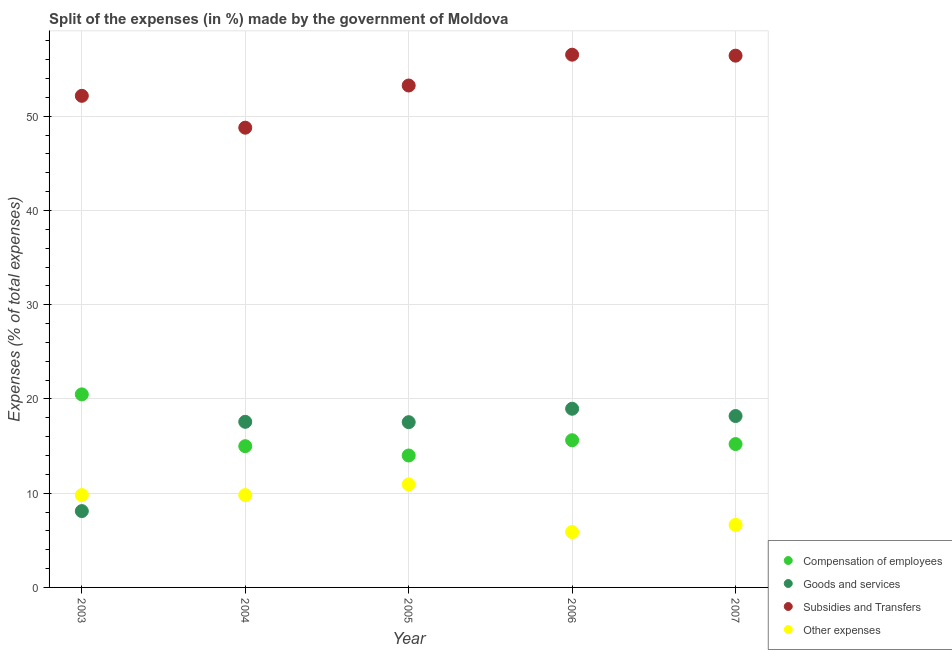How many different coloured dotlines are there?
Provide a short and direct response. 4. Is the number of dotlines equal to the number of legend labels?
Provide a succinct answer. Yes. What is the percentage of amount spent on other expenses in 2006?
Your answer should be very brief. 5.88. Across all years, what is the maximum percentage of amount spent on goods and services?
Make the answer very short. 18.96. Across all years, what is the minimum percentage of amount spent on compensation of employees?
Ensure brevity in your answer.  14. What is the total percentage of amount spent on compensation of employees in the graph?
Ensure brevity in your answer.  80.31. What is the difference between the percentage of amount spent on goods and services in 2003 and that in 2005?
Keep it short and to the point. -9.44. What is the difference between the percentage of amount spent on compensation of employees in 2003 and the percentage of amount spent on subsidies in 2005?
Your answer should be compact. -32.78. What is the average percentage of amount spent on goods and services per year?
Offer a very short reply. 16.07. In the year 2005, what is the difference between the percentage of amount spent on other expenses and percentage of amount spent on compensation of employees?
Provide a short and direct response. -3.06. In how many years, is the percentage of amount spent on subsidies greater than 42 %?
Offer a terse response. 5. What is the ratio of the percentage of amount spent on subsidies in 2003 to that in 2004?
Offer a terse response. 1.07. Is the percentage of amount spent on subsidies in 2003 less than that in 2007?
Provide a succinct answer. Yes. What is the difference between the highest and the second highest percentage of amount spent on other expenses?
Your answer should be very brief. 1.14. What is the difference between the highest and the lowest percentage of amount spent on goods and services?
Provide a short and direct response. 10.86. In how many years, is the percentage of amount spent on compensation of employees greater than the average percentage of amount spent on compensation of employees taken over all years?
Keep it short and to the point. 1. Is the sum of the percentage of amount spent on goods and services in 2003 and 2006 greater than the maximum percentage of amount spent on compensation of employees across all years?
Make the answer very short. Yes. Is it the case that in every year, the sum of the percentage of amount spent on compensation of employees and percentage of amount spent on goods and services is greater than the percentage of amount spent on subsidies?
Your answer should be very brief. No. Does the percentage of amount spent on other expenses monotonically increase over the years?
Give a very brief answer. No. Is the percentage of amount spent on compensation of employees strictly greater than the percentage of amount spent on other expenses over the years?
Offer a terse response. Yes. How many dotlines are there?
Your answer should be compact. 4. How many years are there in the graph?
Your response must be concise. 5. Does the graph contain any zero values?
Provide a succinct answer. No. Does the graph contain grids?
Keep it short and to the point. Yes. How many legend labels are there?
Provide a succinct answer. 4. What is the title of the graph?
Provide a succinct answer. Split of the expenses (in %) made by the government of Moldova. Does "UNPBF" appear as one of the legend labels in the graph?
Your answer should be compact. No. What is the label or title of the X-axis?
Offer a very short reply. Year. What is the label or title of the Y-axis?
Your response must be concise. Expenses (% of total expenses). What is the Expenses (% of total expenses) in Compensation of employees in 2003?
Offer a terse response. 20.49. What is the Expenses (% of total expenses) of Goods and services in 2003?
Ensure brevity in your answer.  8.1. What is the Expenses (% of total expenses) in Subsidies and Transfers in 2003?
Provide a short and direct response. 52.17. What is the Expenses (% of total expenses) of Other expenses in 2003?
Your response must be concise. 9.8. What is the Expenses (% of total expenses) in Compensation of employees in 2004?
Ensure brevity in your answer.  14.99. What is the Expenses (% of total expenses) in Goods and services in 2004?
Keep it short and to the point. 17.57. What is the Expenses (% of total expenses) in Subsidies and Transfers in 2004?
Offer a very short reply. 48.79. What is the Expenses (% of total expenses) of Other expenses in 2004?
Provide a short and direct response. 9.8. What is the Expenses (% of total expenses) of Compensation of employees in 2005?
Provide a short and direct response. 14. What is the Expenses (% of total expenses) in Goods and services in 2005?
Provide a succinct answer. 17.54. What is the Expenses (% of total expenses) in Subsidies and Transfers in 2005?
Offer a very short reply. 53.26. What is the Expenses (% of total expenses) in Other expenses in 2005?
Give a very brief answer. 10.94. What is the Expenses (% of total expenses) in Compensation of employees in 2006?
Provide a short and direct response. 15.62. What is the Expenses (% of total expenses) in Goods and services in 2006?
Offer a very short reply. 18.96. What is the Expenses (% of total expenses) in Subsidies and Transfers in 2006?
Offer a terse response. 56.54. What is the Expenses (% of total expenses) of Other expenses in 2006?
Ensure brevity in your answer.  5.88. What is the Expenses (% of total expenses) in Compensation of employees in 2007?
Make the answer very short. 15.21. What is the Expenses (% of total expenses) in Goods and services in 2007?
Ensure brevity in your answer.  18.19. What is the Expenses (% of total expenses) of Subsidies and Transfers in 2007?
Make the answer very short. 56.43. What is the Expenses (% of total expenses) in Other expenses in 2007?
Give a very brief answer. 6.64. Across all years, what is the maximum Expenses (% of total expenses) of Compensation of employees?
Provide a short and direct response. 20.49. Across all years, what is the maximum Expenses (% of total expenses) in Goods and services?
Your answer should be compact. 18.96. Across all years, what is the maximum Expenses (% of total expenses) of Subsidies and Transfers?
Your answer should be very brief. 56.54. Across all years, what is the maximum Expenses (% of total expenses) of Other expenses?
Your response must be concise. 10.94. Across all years, what is the minimum Expenses (% of total expenses) of Compensation of employees?
Provide a short and direct response. 14. Across all years, what is the minimum Expenses (% of total expenses) in Goods and services?
Your answer should be very brief. 8.1. Across all years, what is the minimum Expenses (% of total expenses) in Subsidies and Transfers?
Provide a succinct answer. 48.79. Across all years, what is the minimum Expenses (% of total expenses) in Other expenses?
Provide a succinct answer. 5.88. What is the total Expenses (% of total expenses) of Compensation of employees in the graph?
Offer a terse response. 80.31. What is the total Expenses (% of total expenses) in Goods and services in the graph?
Offer a terse response. 80.36. What is the total Expenses (% of total expenses) of Subsidies and Transfers in the graph?
Offer a terse response. 267.19. What is the total Expenses (% of total expenses) in Other expenses in the graph?
Your response must be concise. 43.05. What is the difference between the Expenses (% of total expenses) in Compensation of employees in 2003 and that in 2004?
Your answer should be very brief. 5.5. What is the difference between the Expenses (% of total expenses) of Goods and services in 2003 and that in 2004?
Your response must be concise. -9.47. What is the difference between the Expenses (% of total expenses) of Subsidies and Transfers in 2003 and that in 2004?
Keep it short and to the point. 3.38. What is the difference between the Expenses (% of total expenses) in Other expenses in 2003 and that in 2004?
Provide a succinct answer. 0. What is the difference between the Expenses (% of total expenses) in Compensation of employees in 2003 and that in 2005?
Provide a short and direct response. 6.49. What is the difference between the Expenses (% of total expenses) in Goods and services in 2003 and that in 2005?
Your response must be concise. -9.44. What is the difference between the Expenses (% of total expenses) in Subsidies and Transfers in 2003 and that in 2005?
Give a very brief answer. -1.1. What is the difference between the Expenses (% of total expenses) in Other expenses in 2003 and that in 2005?
Your answer should be compact. -1.14. What is the difference between the Expenses (% of total expenses) of Compensation of employees in 2003 and that in 2006?
Offer a very short reply. 4.87. What is the difference between the Expenses (% of total expenses) of Goods and services in 2003 and that in 2006?
Ensure brevity in your answer.  -10.86. What is the difference between the Expenses (% of total expenses) of Subsidies and Transfers in 2003 and that in 2006?
Keep it short and to the point. -4.37. What is the difference between the Expenses (% of total expenses) in Other expenses in 2003 and that in 2006?
Your answer should be compact. 3.92. What is the difference between the Expenses (% of total expenses) of Compensation of employees in 2003 and that in 2007?
Provide a short and direct response. 5.27. What is the difference between the Expenses (% of total expenses) in Goods and services in 2003 and that in 2007?
Offer a very short reply. -10.09. What is the difference between the Expenses (% of total expenses) in Subsidies and Transfers in 2003 and that in 2007?
Keep it short and to the point. -4.26. What is the difference between the Expenses (% of total expenses) in Other expenses in 2003 and that in 2007?
Offer a terse response. 3.16. What is the difference between the Expenses (% of total expenses) of Goods and services in 2004 and that in 2005?
Give a very brief answer. 0.04. What is the difference between the Expenses (% of total expenses) of Subsidies and Transfers in 2004 and that in 2005?
Your answer should be compact. -4.48. What is the difference between the Expenses (% of total expenses) in Other expenses in 2004 and that in 2005?
Offer a terse response. -1.14. What is the difference between the Expenses (% of total expenses) of Compensation of employees in 2004 and that in 2006?
Ensure brevity in your answer.  -0.63. What is the difference between the Expenses (% of total expenses) in Goods and services in 2004 and that in 2006?
Offer a very short reply. -1.39. What is the difference between the Expenses (% of total expenses) in Subsidies and Transfers in 2004 and that in 2006?
Make the answer very short. -7.75. What is the difference between the Expenses (% of total expenses) in Other expenses in 2004 and that in 2006?
Offer a terse response. 3.92. What is the difference between the Expenses (% of total expenses) of Compensation of employees in 2004 and that in 2007?
Provide a succinct answer. -0.22. What is the difference between the Expenses (% of total expenses) of Goods and services in 2004 and that in 2007?
Your response must be concise. -0.61. What is the difference between the Expenses (% of total expenses) of Subsidies and Transfers in 2004 and that in 2007?
Your answer should be compact. -7.64. What is the difference between the Expenses (% of total expenses) of Other expenses in 2004 and that in 2007?
Your answer should be very brief. 3.15. What is the difference between the Expenses (% of total expenses) of Compensation of employees in 2005 and that in 2006?
Provide a succinct answer. -1.62. What is the difference between the Expenses (% of total expenses) in Goods and services in 2005 and that in 2006?
Ensure brevity in your answer.  -1.42. What is the difference between the Expenses (% of total expenses) of Subsidies and Transfers in 2005 and that in 2006?
Offer a very short reply. -3.27. What is the difference between the Expenses (% of total expenses) in Other expenses in 2005 and that in 2006?
Make the answer very short. 5.06. What is the difference between the Expenses (% of total expenses) of Compensation of employees in 2005 and that in 2007?
Keep it short and to the point. -1.21. What is the difference between the Expenses (% of total expenses) in Goods and services in 2005 and that in 2007?
Provide a short and direct response. -0.65. What is the difference between the Expenses (% of total expenses) in Subsidies and Transfers in 2005 and that in 2007?
Your answer should be very brief. -3.17. What is the difference between the Expenses (% of total expenses) in Other expenses in 2005 and that in 2007?
Make the answer very short. 4.29. What is the difference between the Expenses (% of total expenses) of Compensation of employees in 2006 and that in 2007?
Offer a very short reply. 0.41. What is the difference between the Expenses (% of total expenses) of Goods and services in 2006 and that in 2007?
Offer a terse response. 0.77. What is the difference between the Expenses (% of total expenses) of Subsidies and Transfers in 2006 and that in 2007?
Keep it short and to the point. 0.1. What is the difference between the Expenses (% of total expenses) of Other expenses in 2006 and that in 2007?
Your response must be concise. -0.77. What is the difference between the Expenses (% of total expenses) in Compensation of employees in 2003 and the Expenses (% of total expenses) in Goods and services in 2004?
Keep it short and to the point. 2.91. What is the difference between the Expenses (% of total expenses) of Compensation of employees in 2003 and the Expenses (% of total expenses) of Subsidies and Transfers in 2004?
Offer a terse response. -28.3. What is the difference between the Expenses (% of total expenses) of Compensation of employees in 2003 and the Expenses (% of total expenses) of Other expenses in 2004?
Provide a short and direct response. 10.69. What is the difference between the Expenses (% of total expenses) of Goods and services in 2003 and the Expenses (% of total expenses) of Subsidies and Transfers in 2004?
Provide a short and direct response. -40.69. What is the difference between the Expenses (% of total expenses) of Goods and services in 2003 and the Expenses (% of total expenses) of Other expenses in 2004?
Make the answer very short. -1.7. What is the difference between the Expenses (% of total expenses) of Subsidies and Transfers in 2003 and the Expenses (% of total expenses) of Other expenses in 2004?
Give a very brief answer. 42.37. What is the difference between the Expenses (% of total expenses) in Compensation of employees in 2003 and the Expenses (% of total expenses) in Goods and services in 2005?
Offer a terse response. 2.95. What is the difference between the Expenses (% of total expenses) of Compensation of employees in 2003 and the Expenses (% of total expenses) of Subsidies and Transfers in 2005?
Offer a terse response. -32.78. What is the difference between the Expenses (% of total expenses) in Compensation of employees in 2003 and the Expenses (% of total expenses) in Other expenses in 2005?
Your response must be concise. 9.55. What is the difference between the Expenses (% of total expenses) of Goods and services in 2003 and the Expenses (% of total expenses) of Subsidies and Transfers in 2005?
Your response must be concise. -45.16. What is the difference between the Expenses (% of total expenses) of Goods and services in 2003 and the Expenses (% of total expenses) of Other expenses in 2005?
Offer a very short reply. -2.84. What is the difference between the Expenses (% of total expenses) of Subsidies and Transfers in 2003 and the Expenses (% of total expenses) of Other expenses in 2005?
Provide a succinct answer. 41.23. What is the difference between the Expenses (% of total expenses) in Compensation of employees in 2003 and the Expenses (% of total expenses) in Goods and services in 2006?
Your response must be concise. 1.53. What is the difference between the Expenses (% of total expenses) of Compensation of employees in 2003 and the Expenses (% of total expenses) of Subsidies and Transfers in 2006?
Give a very brief answer. -36.05. What is the difference between the Expenses (% of total expenses) in Compensation of employees in 2003 and the Expenses (% of total expenses) in Other expenses in 2006?
Provide a succinct answer. 14.61. What is the difference between the Expenses (% of total expenses) in Goods and services in 2003 and the Expenses (% of total expenses) in Subsidies and Transfers in 2006?
Provide a succinct answer. -48.44. What is the difference between the Expenses (% of total expenses) of Goods and services in 2003 and the Expenses (% of total expenses) of Other expenses in 2006?
Give a very brief answer. 2.22. What is the difference between the Expenses (% of total expenses) of Subsidies and Transfers in 2003 and the Expenses (% of total expenses) of Other expenses in 2006?
Your response must be concise. 46.29. What is the difference between the Expenses (% of total expenses) in Compensation of employees in 2003 and the Expenses (% of total expenses) in Goods and services in 2007?
Give a very brief answer. 2.3. What is the difference between the Expenses (% of total expenses) of Compensation of employees in 2003 and the Expenses (% of total expenses) of Subsidies and Transfers in 2007?
Keep it short and to the point. -35.94. What is the difference between the Expenses (% of total expenses) in Compensation of employees in 2003 and the Expenses (% of total expenses) in Other expenses in 2007?
Your response must be concise. 13.84. What is the difference between the Expenses (% of total expenses) of Goods and services in 2003 and the Expenses (% of total expenses) of Subsidies and Transfers in 2007?
Give a very brief answer. -48.33. What is the difference between the Expenses (% of total expenses) of Goods and services in 2003 and the Expenses (% of total expenses) of Other expenses in 2007?
Provide a succinct answer. 1.46. What is the difference between the Expenses (% of total expenses) in Subsidies and Transfers in 2003 and the Expenses (% of total expenses) in Other expenses in 2007?
Your answer should be compact. 45.53. What is the difference between the Expenses (% of total expenses) of Compensation of employees in 2004 and the Expenses (% of total expenses) of Goods and services in 2005?
Your response must be concise. -2.55. What is the difference between the Expenses (% of total expenses) of Compensation of employees in 2004 and the Expenses (% of total expenses) of Subsidies and Transfers in 2005?
Offer a very short reply. -38.27. What is the difference between the Expenses (% of total expenses) of Compensation of employees in 2004 and the Expenses (% of total expenses) of Other expenses in 2005?
Make the answer very short. 4.05. What is the difference between the Expenses (% of total expenses) in Goods and services in 2004 and the Expenses (% of total expenses) in Subsidies and Transfers in 2005?
Provide a succinct answer. -35.69. What is the difference between the Expenses (% of total expenses) in Goods and services in 2004 and the Expenses (% of total expenses) in Other expenses in 2005?
Offer a terse response. 6.64. What is the difference between the Expenses (% of total expenses) in Subsidies and Transfers in 2004 and the Expenses (% of total expenses) in Other expenses in 2005?
Provide a succinct answer. 37.85. What is the difference between the Expenses (% of total expenses) of Compensation of employees in 2004 and the Expenses (% of total expenses) of Goods and services in 2006?
Offer a terse response. -3.97. What is the difference between the Expenses (% of total expenses) in Compensation of employees in 2004 and the Expenses (% of total expenses) in Subsidies and Transfers in 2006?
Offer a terse response. -41.55. What is the difference between the Expenses (% of total expenses) of Compensation of employees in 2004 and the Expenses (% of total expenses) of Other expenses in 2006?
Give a very brief answer. 9.11. What is the difference between the Expenses (% of total expenses) of Goods and services in 2004 and the Expenses (% of total expenses) of Subsidies and Transfers in 2006?
Your answer should be very brief. -38.96. What is the difference between the Expenses (% of total expenses) of Goods and services in 2004 and the Expenses (% of total expenses) of Other expenses in 2006?
Your answer should be very brief. 11.7. What is the difference between the Expenses (% of total expenses) in Subsidies and Transfers in 2004 and the Expenses (% of total expenses) in Other expenses in 2006?
Your response must be concise. 42.91. What is the difference between the Expenses (% of total expenses) of Compensation of employees in 2004 and the Expenses (% of total expenses) of Goods and services in 2007?
Give a very brief answer. -3.2. What is the difference between the Expenses (% of total expenses) of Compensation of employees in 2004 and the Expenses (% of total expenses) of Subsidies and Transfers in 2007?
Your response must be concise. -41.44. What is the difference between the Expenses (% of total expenses) in Compensation of employees in 2004 and the Expenses (% of total expenses) in Other expenses in 2007?
Make the answer very short. 8.35. What is the difference between the Expenses (% of total expenses) of Goods and services in 2004 and the Expenses (% of total expenses) of Subsidies and Transfers in 2007?
Give a very brief answer. -38.86. What is the difference between the Expenses (% of total expenses) of Goods and services in 2004 and the Expenses (% of total expenses) of Other expenses in 2007?
Ensure brevity in your answer.  10.93. What is the difference between the Expenses (% of total expenses) in Subsidies and Transfers in 2004 and the Expenses (% of total expenses) in Other expenses in 2007?
Offer a terse response. 42.14. What is the difference between the Expenses (% of total expenses) of Compensation of employees in 2005 and the Expenses (% of total expenses) of Goods and services in 2006?
Give a very brief answer. -4.96. What is the difference between the Expenses (% of total expenses) in Compensation of employees in 2005 and the Expenses (% of total expenses) in Subsidies and Transfers in 2006?
Ensure brevity in your answer.  -42.54. What is the difference between the Expenses (% of total expenses) of Compensation of employees in 2005 and the Expenses (% of total expenses) of Other expenses in 2006?
Offer a very short reply. 8.12. What is the difference between the Expenses (% of total expenses) of Goods and services in 2005 and the Expenses (% of total expenses) of Subsidies and Transfers in 2006?
Offer a terse response. -39. What is the difference between the Expenses (% of total expenses) in Goods and services in 2005 and the Expenses (% of total expenses) in Other expenses in 2006?
Ensure brevity in your answer.  11.66. What is the difference between the Expenses (% of total expenses) of Subsidies and Transfers in 2005 and the Expenses (% of total expenses) of Other expenses in 2006?
Offer a terse response. 47.39. What is the difference between the Expenses (% of total expenses) in Compensation of employees in 2005 and the Expenses (% of total expenses) in Goods and services in 2007?
Your answer should be compact. -4.19. What is the difference between the Expenses (% of total expenses) of Compensation of employees in 2005 and the Expenses (% of total expenses) of Subsidies and Transfers in 2007?
Make the answer very short. -42.43. What is the difference between the Expenses (% of total expenses) in Compensation of employees in 2005 and the Expenses (% of total expenses) in Other expenses in 2007?
Offer a very short reply. 7.36. What is the difference between the Expenses (% of total expenses) in Goods and services in 2005 and the Expenses (% of total expenses) in Subsidies and Transfers in 2007?
Your response must be concise. -38.89. What is the difference between the Expenses (% of total expenses) in Goods and services in 2005 and the Expenses (% of total expenses) in Other expenses in 2007?
Your response must be concise. 10.89. What is the difference between the Expenses (% of total expenses) in Subsidies and Transfers in 2005 and the Expenses (% of total expenses) in Other expenses in 2007?
Your response must be concise. 46.62. What is the difference between the Expenses (% of total expenses) of Compensation of employees in 2006 and the Expenses (% of total expenses) of Goods and services in 2007?
Your answer should be compact. -2.57. What is the difference between the Expenses (% of total expenses) in Compensation of employees in 2006 and the Expenses (% of total expenses) in Subsidies and Transfers in 2007?
Keep it short and to the point. -40.81. What is the difference between the Expenses (% of total expenses) in Compensation of employees in 2006 and the Expenses (% of total expenses) in Other expenses in 2007?
Give a very brief answer. 8.98. What is the difference between the Expenses (% of total expenses) in Goods and services in 2006 and the Expenses (% of total expenses) in Subsidies and Transfers in 2007?
Your response must be concise. -37.47. What is the difference between the Expenses (% of total expenses) of Goods and services in 2006 and the Expenses (% of total expenses) of Other expenses in 2007?
Offer a very short reply. 12.32. What is the difference between the Expenses (% of total expenses) of Subsidies and Transfers in 2006 and the Expenses (% of total expenses) of Other expenses in 2007?
Make the answer very short. 49.89. What is the average Expenses (% of total expenses) of Compensation of employees per year?
Make the answer very short. 16.06. What is the average Expenses (% of total expenses) of Goods and services per year?
Give a very brief answer. 16.07. What is the average Expenses (% of total expenses) in Subsidies and Transfers per year?
Your response must be concise. 53.44. What is the average Expenses (% of total expenses) in Other expenses per year?
Make the answer very short. 8.61. In the year 2003, what is the difference between the Expenses (% of total expenses) of Compensation of employees and Expenses (% of total expenses) of Goods and services?
Provide a succinct answer. 12.39. In the year 2003, what is the difference between the Expenses (% of total expenses) in Compensation of employees and Expenses (% of total expenses) in Subsidies and Transfers?
Provide a short and direct response. -31.68. In the year 2003, what is the difference between the Expenses (% of total expenses) in Compensation of employees and Expenses (% of total expenses) in Other expenses?
Your response must be concise. 10.69. In the year 2003, what is the difference between the Expenses (% of total expenses) in Goods and services and Expenses (% of total expenses) in Subsidies and Transfers?
Ensure brevity in your answer.  -44.07. In the year 2003, what is the difference between the Expenses (% of total expenses) of Goods and services and Expenses (% of total expenses) of Other expenses?
Ensure brevity in your answer.  -1.7. In the year 2003, what is the difference between the Expenses (% of total expenses) in Subsidies and Transfers and Expenses (% of total expenses) in Other expenses?
Provide a succinct answer. 42.37. In the year 2004, what is the difference between the Expenses (% of total expenses) of Compensation of employees and Expenses (% of total expenses) of Goods and services?
Make the answer very short. -2.58. In the year 2004, what is the difference between the Expenses (% of total expenses) of Compensation of employees and Expenses (% of total expenses) of Subsidies and Transfers?
Your answer should be very brief. -33.8. In the year 2004, what is the difference between the Expenses (% of total expenses) in Compensation of employees and Expenses (% of total expenses) in Other expenses?
Your answer should be very brief. 5.19. In the year 2004, what is the difference between the Expenses (% of total expenses) of Goods and services and Expenses (% of total expenses) of Subsidies and Transfers?
Give a very brief answer. -31.21. In the year 2004, what is the difference between the Expenses (% of total expenses) of Goods and services and Expenses (% of total expenses) of Other expenses?
Your answer should be very brief. 7.78. In the year 2004, what is the difference between the Expenses (% of total expenses) of Subsidies and Transfers and Expenses (% of total expenses) of Other expenses?
Your answer should be very brief. 38.99. In the year 2005, what is the difference between the Expenses (% of total expenses) of Compensation of employees and Expenses (% of total expenses) of Goods and services?
Your answer should be compact. -3.54. In the year 2005, what is the difference between the Expenses (% of total expenses) in Compensation of employees and Expenses (% of total expenses) in Subsidies and Transfers?
Offer a very short reply. -39.26. In the year 2005, what is the difference between the Expenses (% of total expenses) in Compensation of employees and Expenses (% of total expenses) in Other expenses?
Offer a terse response. 3.06. In the year 2005, what is the difference between the Expenses (% of total expenses) in Goods and services and Expenses (% of total expenses) in Subsidies and Transfers?
Offer a very short reply. -35.73. In the year 2005, what is the difference between the Expenses (% of total expenses) of Goods and services and Expenses (% of total expenses) of Other expenses?
Provide a succinct answer. 6.6. In the year 2005, what is the difference between the Expenses (% of total expenses) of Subsidies and Transfers and Expenses (% of total expenses) of Other expenses?
Offer a very short reply. 42.33. In the year 2006, what is the difference between the Expenses (% of total expenses) in Compensation of employees and Expenses (% of total expenses) in Goods and services?
Make the answer very short. -3.34. In the year 2006, what is the difference between the Expenses (% of total expenses) in Compensation of employees and Expenses (% of total expenses) in Subsidies and Transfers?
Provide a short and direct response. -40.91. In the year 2006, what is the difference between the Expenses (% of total expenses) of Compensation of employees and Expenses (% of total expenses) of Other expenses?
Your response must be concise. 9.74. In the year 2006, what is the difference between the Expenses (% of total expenses) of Goods and services and Expenses (% of total expenses) of Subsidies and Transfers?
Give a very brief answer. -37.57. In the year 2006, what is the difference between the Expenses (% of total expenses) in Goods and services and Expenses (% of total expenses) in Other expenses?
Keep it short and to the point. 13.08. In the year 2006, what is the difference between the Expenses (% of total expenses) in Subsidies and Transfers and Expenses (% of total expenses) in Other expenses?
Offer a terse response. 50.66. In the year 2007, what is the difference between the Expenses (% of total expenses) of Compensation of employees and Expenses (% of total expenses) of Goods and services?
Make the answer very short. -2.98. In the year 2007, what is the difference between the Expenses (% of total expenses) in Compensation of employees and Expenses (% of total expenses) in Subsidies and Transfers?
Provide a short and direct response. -41.22. In the year 2007, what is the difference between the Expenses (% of total expenses) of Compensation of employees and Expenses (% of total expenses) of Other expenses?
Ensure brevity in your answer.  8.57. In the year 2007, what is the difference between the Expenses (% of total expenses) in Goods and services and Expenses (% of total expenses) in Subsidies and Transfers?
Keep it short and to the point. -38.24. In the year 2007, what is the difference between the Expenses (% of total expenses) in Goods and services and Expenses (% of total expenses) in Other expenses?
Your response must be concise. 11.55. In the year 2007, what is the difference between the Expenses (% of total expenses) of Subsidies and Transfers and Expenses (% of total expenses) of Other expenses?
Offer a terse response. 49.79. What is the ratio of the Expenses (% of total expenses) in Compensation of employees in 2003 to that in 2004?
Offer a terse response. 1.37. What is the ratio of the Expenses (% of total expenses) of Goods and services in 2003 to that in 2004?
Your answer should be compact. 0.46. What is the ratio of the Expenses (% of total expenses) of Subsidies and Transfers in 2003 to that in 2004?
Offer a very short reply. 1.07. What is the ratio of the Expenses (% of total expenses) of Other expenses in 2003 to that in 2004?
Provide a succinct answer. 1. What is the ratio of the Expenses (% of total expenses) of Compensation of employees in 2003 to that in 2005?
Provide a short and direct response. 1.46. What is the ratio of the Expenses (% of total expenses) in Goods and services in 2003 to that in 2005?
Make the answer very short. 0.46. What is the ratio of the Expenses (% of total expenses) of Subsidies and Transfers in 2003 to that in 2005?
Offer a terse response. 0.98. What is the ratio of the Expenses (% of total expenses) of Other expenses in 2003 to that in 2005?
Give a very brief answer. 0.9. What is the ratio of the Expenses (% of total expenses) of Compensation of employees in 2003 to that in 2006?
Make the answer very short. 1.31. What is the ratio of the Expenses (% of total expenses) of Goods and services in 2003 to that in 2006?
Offer a very short reply. 0.43. What is the ratio of the Expenses (% of total expenses) of Subsidies and Transfers in 2003 to that in 2006?
Keep it short and to the point. 0.92. What is the ratio of the Expenses (% of total expenses) in Other expenses in 2003 to that in 2006?
Your answer should be very brief. 1.67. What is the ratio of the Expenses (% of total expenses) of Compensation of employees in 2003 to that in 2007?
Provide a succinct answer. 1.35. What is the ratio of the Expenses (% of total expenses) of Goods and services in 2003 to that in 2007?
Provide a short and direct response. 0.45. What is the ratio of the Expenses (% of total expenses) of Subsidies and Transfers in 2003 to that in 2007?
Your answer should be very brief. 0.92. What is the ratio of the Expenses (% of total expenses) in Other expenses in 2003 to that in 2007?
Your answer should be compact. 1.47. What is the ratio of the Expenses (% of total expenses) of Compensation of employees in 2004 to that in 2005?
Keep it short and to the point. 1.07. What is the ratio of the Expenses (% of total expenses) in Goods and services in 2004 to that in 2005?
Give a very brief answer. 1. What is the ratio of the Expenses (% of total expenses) in Subsidies and Transfers in 2004 to that in 2005?
Provide a short and direct response. 0.92. What is the ratio of the Expenses (% of total expenses) of Other expenses in 2004 to that in 2005?
Keep it short and to the point. 0.9. What is the ratio of the Expenses (% of total expenses) of Compensation of employees in 2004 to that in 2006?
Offer a very short reply. 0.96. What is the ratio of the Expenses (% of total expenses) in Goods and services in 2004 to that in 2006?
Your answer should be very brief. 0.93. What is the ratio of the Expenses (% of total expenses) in Subsidies and Transfers in 2004 to that in 2006?
Keep it short and to the point. 0.86. What is the ratio of the Expenses (% of total expenses) of Other expenses in 2004 to that in 2006?
Keep it short and to the point. 1.67. What is the ratio of the Expenses (% of total expenses) of Compensation of employees in 2004 to that in 2007?
Keep it short and to the point. 0.99. What is the ratio of the Expenses (% of total expenses) of Goods and services in 2004 to that in 2007?
Provide a succinct answer. 0.97. What is the ratio of the Expenses (% of total expenses) of Subsidies and Transfers in 2004 to that in 2007?
Offer a terse response. 0.86. What is the ratio of the Expenses (% of total expenses) of Other expenses in 2004 to that in 2007?
Your answer should be very brief. 1.47. What is the ratio of the Expenses (% of total expenses) of Compensation of employees in 2005 to that in 2006?
Ensure brevity in your answer.  0.9. What is the ratio of the Expenses (% of total expenses) of Goods and services in 2005 to that in 2006?
Your response must be concise. 0.92. What is the ratio of the Expenses (% of total expenses) of Subsidies and Transfers in 2005 to that in 2006?
Your answer should be very brief. 0.94. What is the ratio of the Expenses (% of total expenses) of Other expenses in 2005 to that in 2006?
Your answer should be compact. 1.86. What is the ratio of the Expenses (% of total expenses) in Compensation of employees in 2005 to that in 2007?
Your answer should be very brief. 0.92. What is the ratio of the Expenses (% of total expenses) in Goods and services in 2005 to that in 2007?
Keep it short and to the point. 0.96. What is the ratio of the Expenses (% of total expenses) in Subsidies and Transfers in 2005 to that in 2007?
Keep it short and to the point. 0.94. What is the ratio of the Expenses (% of total expenses) of Other expenses in 2005 to that in 2007?
Provide a succinct answer. 1.65. What is the ratio of the Expenses (% of total expenses) in Compensation of employees in 2006 to that in 2007?
Ensure brevity in your answer.  1.03. What is the ratio of the Expenses (% of total expenses) of Goods and services in 2006 to that in 2007?
Provide a succinct answer. 1.04. What is the ratio of the Expenses (% of total expenses) in Other expenses in 2006 to that in 2007?
Your answer should be very brief. 0.88. What is the difference between the highest and the second highest Expenses (% of total expenses) of Compensation of employees?
Keep it short and to the point. 4.87. What is the difference between the highest and the second highest Expenses (% of total expenses) of Goods and services?
Ensure brevity in your answer.  0.77. What is the difference between the highest and the second highest Expenses (% of total expenses) in Subsidies and Transfers?
Ensure brevity in your answer.  0.1. What is the difference between the highest and the second highest Expenses (% of total expenses) in Other expenses?
Your answer should be very brief. 1.14. What is the difference between the highest and the lowest Expenses (% of total expenses) of Compensation of employees?
Your answer should be very brief. 6.49. What is the difference between the highest and the lowest Expenses (% of total expenses) of Goods and services?
Your response must be concise. 10.86. What is the difference between the highest and the lowest Expenses (% of total expenses) in Subsidies and Transfers?
Ensure brevity in your answer.  7.75. What is the difference between the highest and the lowest Expenses (% of total expenses) of Other expenses?
Give a very brief answer. 5.06. 